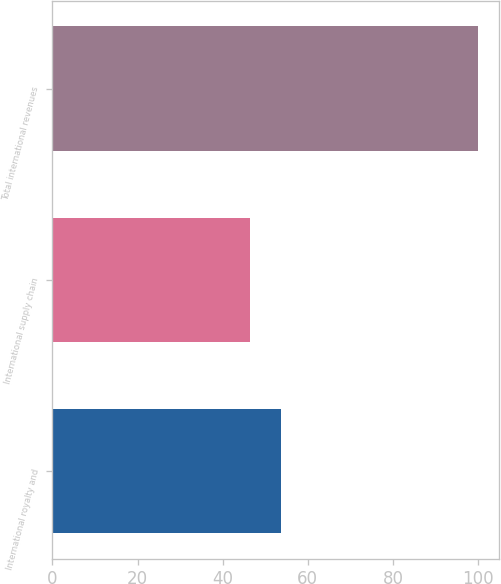Convert chart. <chart><loc_0><loc_0><loc_500><loc_500><bar_chart><fcel>International royalty and<fcel>International supply chain<fcel>Total international revenues<nl><fcel>53.7<fcel>46.3<fcel>100<nl></chart> 